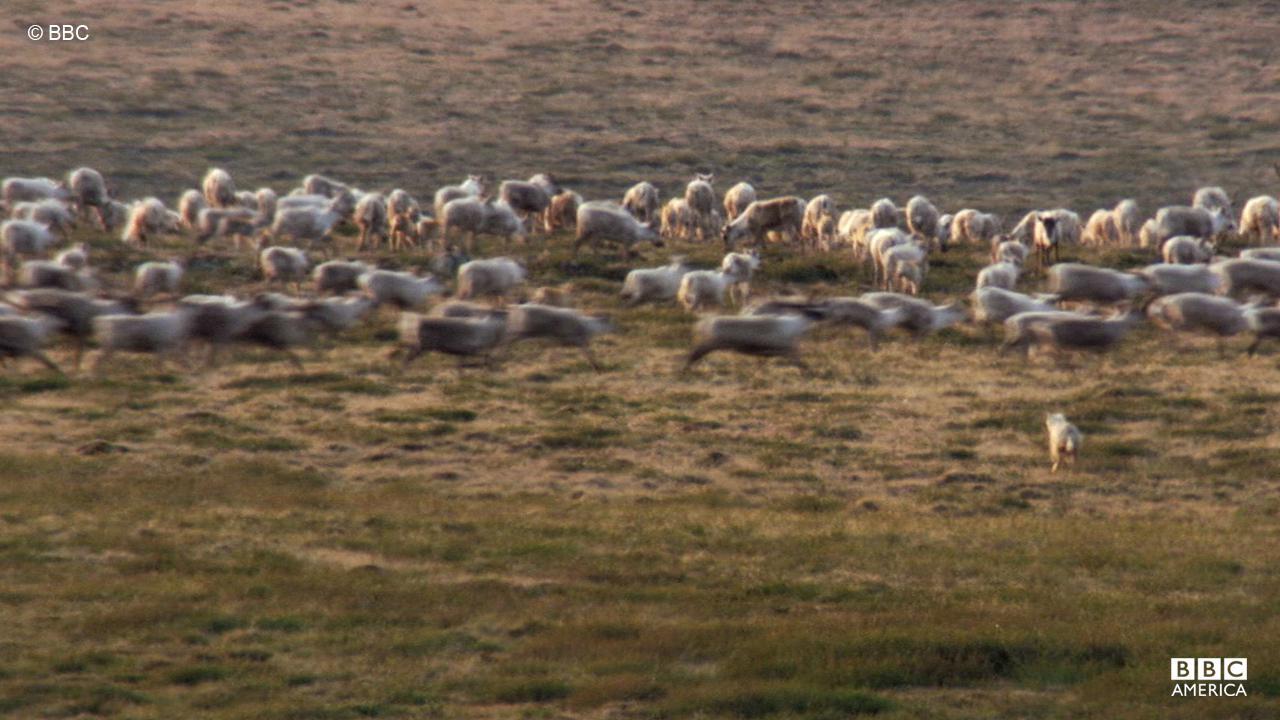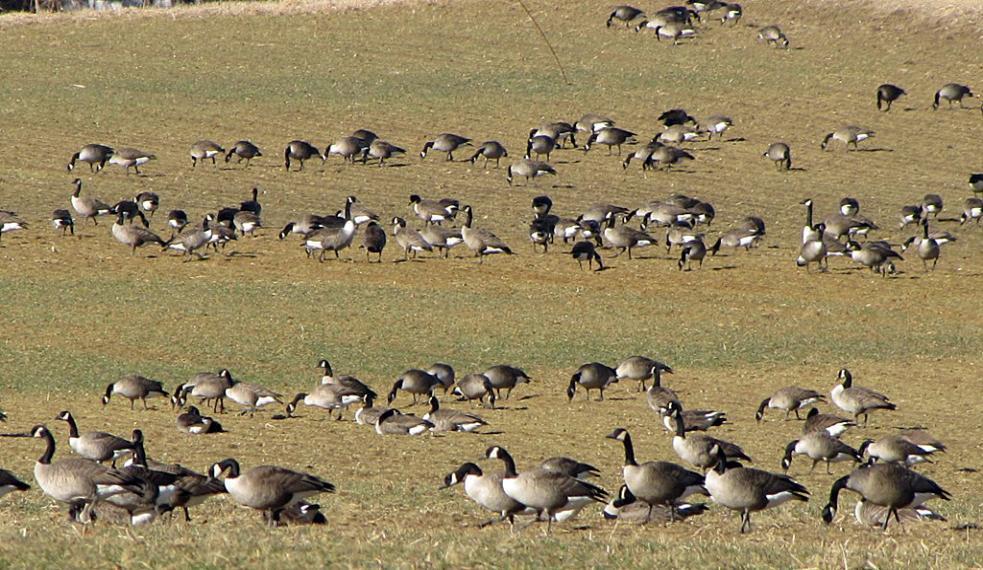The first image is the image on the left, the second image is the image on the right. Considering the images on both sides, is "One of the images in the pair shows a flock of canada geese." valid? Answer yes or no. Yes. 